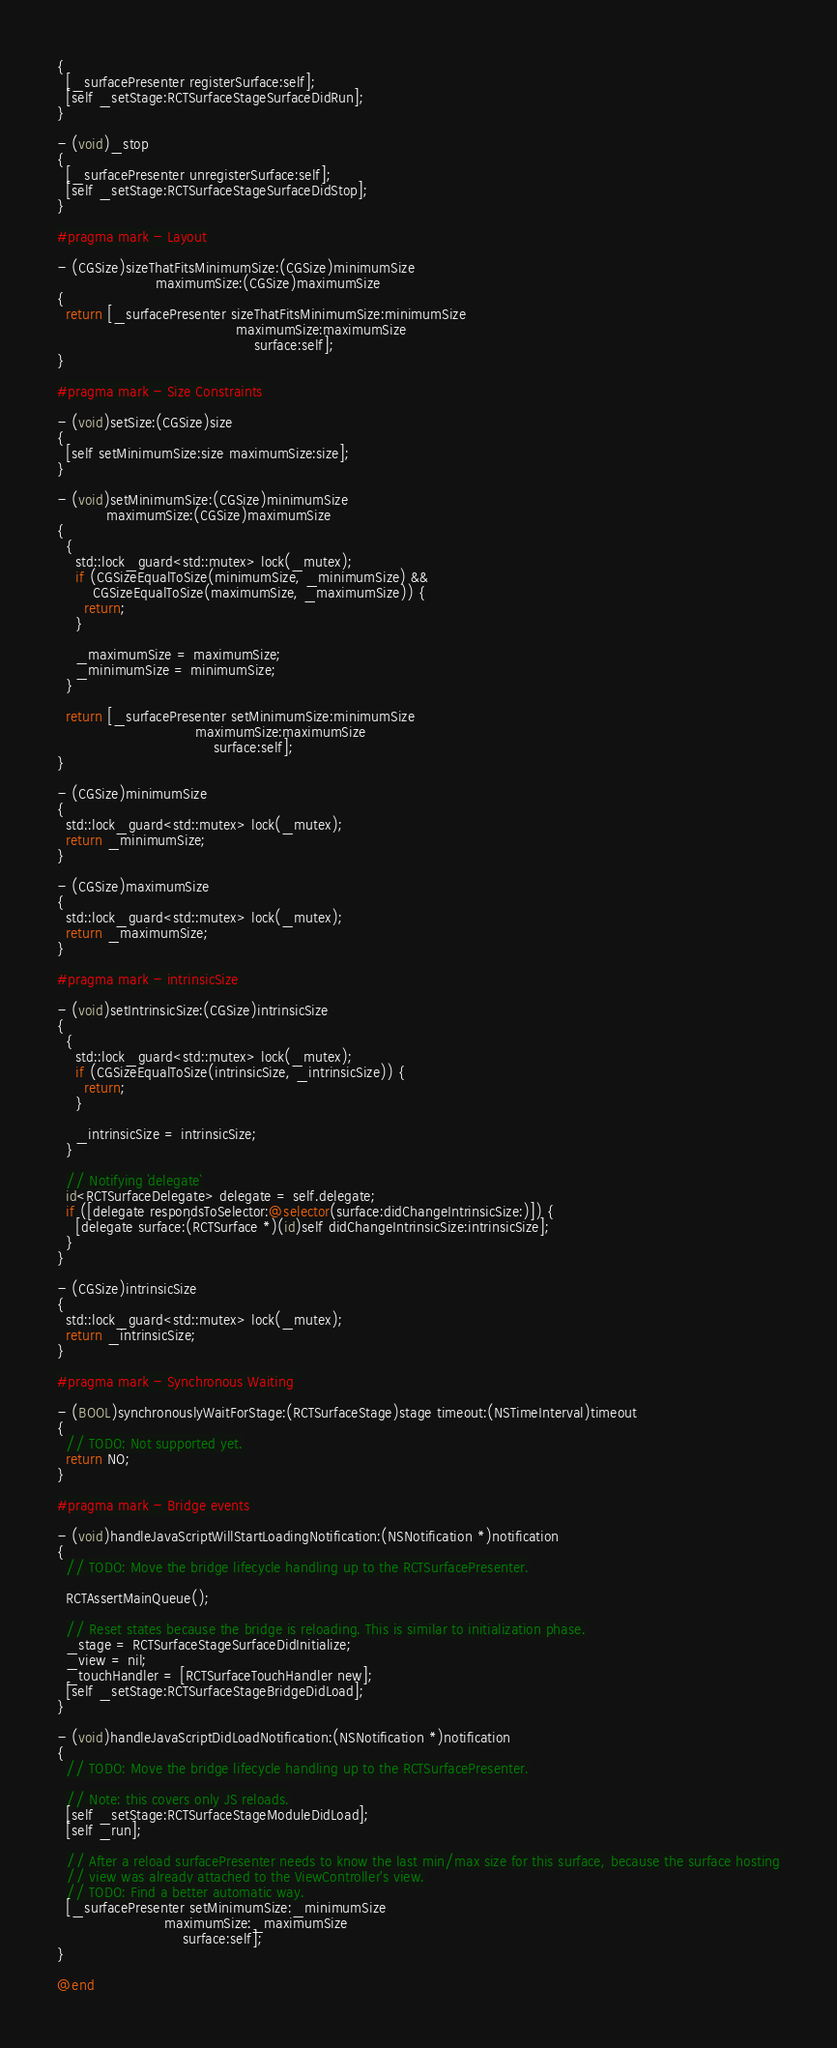Convert code to text. <code><loc_0><loc_0><loc_500><loc_500><_ObjectiveC_>{
  [_surfacePresenter registerSurface:self];
  [self _setStage:RCTSurfaceStageSurfaceDidRun];
}

- (void)_stop
{
  [_surfacePresenter unregisterSurface:self];
  [self _setStage:RCTSurfaceStageSurfaceDidStop];
}

#pragma mark - Layout

- (CGSize)sizeThatFitsMinimumSize:(CGSize)minimumSize
                      maximumSize:(CGSize)maximumSize
{
  return [_surfacePresenter sizeThatFitsMinimumSize:minimumSize
                                        maximumSize:maximumSize
                                            surface:self];
}

#pragma mark - Size Constraints

- (void)setSize:(CGSize)size
{
  [self setMinimumSize:size maximumSize:size];
}

- (void)setMinimumSize:(CGSize)minimumSize
           maximumSize:(CGSize)maximumSize
{
  {
    std::lock_guard<std::mutex> lock(_mutex);
    if (CGSizeEqualToSize(minimumSize, _minimumSize) &&
        CGSizeEqualToSize(maximumSize, _maximumSize)) {
      return;
    }

    _maximumSize = maximumSize;
    _minimumSize = minimumSize;
  }

  return [_surfacePresenter setMinimumSize:minimumSize
                               maximumSize:maximumSize
                                   surface:self];
}

- (CGSize)minimumSize
{
  std::lock_guard<std::mutex> lock(_mutex);
  return _minimumSize;
}

- (CGSize)maximumSize
{
  std::lock_guard<std::mutex> lock(_mutex);
  return _maximumSize;
}

#pragma mark - intrinsicSize

- (void)setIntrinsicSize:(CGSize)intrinsicSize
{
  {
    std::lock_guard<std::mutex> lock(_mutex);
    if (CGSizeEqualToSize(intrinsicSize, _intrinsicSize)) {
      return;
    }

    _intrinsicSize = intrinsicSize;
  }

  // Notifying `delegate`
  id<RCTSurfaceDelegate> delegate = self.delegate;
  if ([delegate respondsToSelector:@selector(surface:didChangeIntrinsicSize:)]) {
    [delegate surface:(RCTSurface *)(id)self didChangeIntrinsicSize:intrinsicSize];
  }
}

- (CGSize)intrinsicSize
{
  std::lock_guard<std::mutex> lock(_mutex);
  return _intrinsicSize;
}

#pragma mark - Synchronous Waiting

- (BOOL)synchronouslyWaitForStage:(RCTSurfaceStage)stage timeout:(NSTimeInterval)timeout
{
  // TODO: Not supported yet.
  return NO;
}

#pragma mark - Bridge events

- (void)handleJavaScriptWillStartLoadingNotification:(NSNotification *)notification
{
  // TODO: Move the bridge lifecycle handling up to the RCTSurfacePresenter.

  RCTAssertMainQueue();

  // Reset states because the bridge is reloading. This is similar to initialization phase.
  _stage = RCTSurfaceStageSurfaceDidInitialize;
  _view = nil;
  _touchHandler = [RCTSurfaceTouchHandler new];
  [self _setStage:RCTSurfaceStageBridgeDidLoad];
}

- (void)handleJavaScriptDidLoadNotification:(NSNotification *)notification
{
  // TODO: Move the bridge lifecycle handling up to the RCTSurfacePresenter.

  // Note: this covers only JS reloads.
  [self _setStage:RCTSurfaceStageModuleDidLoad];
  [self _run];

  // After a reload surfacePresenter needs to know the last min/max size for this surface, because the surface hosting
  // view was already attached to the ViewController's view.
  // TODO: Find a better automatic way.
  [_surfacePresenter setMinimumSize:_minimumSize
                        maximumSize:_maximumSize
                            surface:self];
}

@end
</code> 